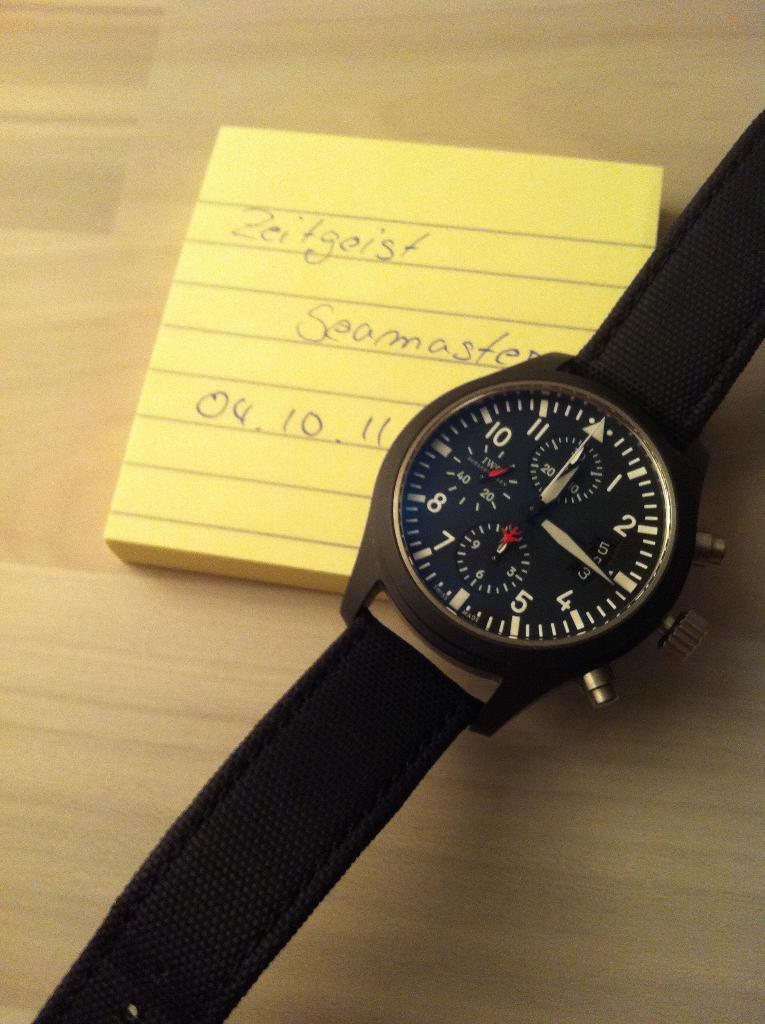<image>
Summarize the visual content of the image. A watch sits on top of a yellow note that says zeitgeist on it. 